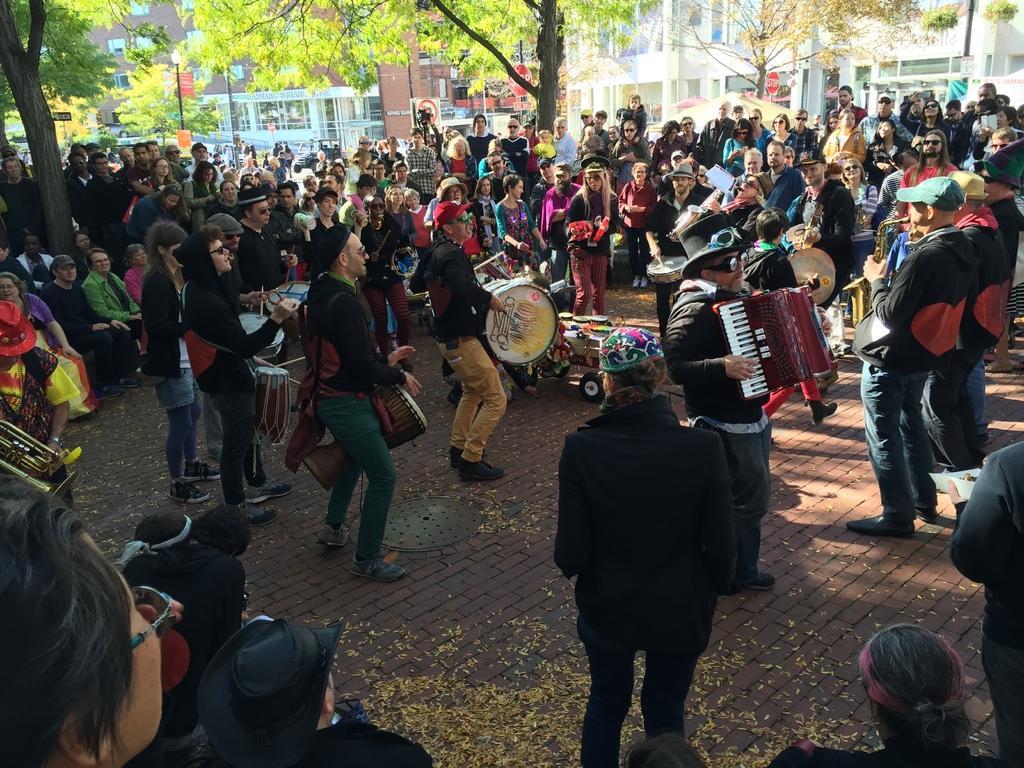Could you give a brief overview of what you see in this image? In this image I can see few people holding the musical instruments. I can see the group of people around these people. And these people are wearing the different color dresses. In the back I can see many trees, building and some red color boards can be seen. I can also see few people are wearing the colorful caps. 